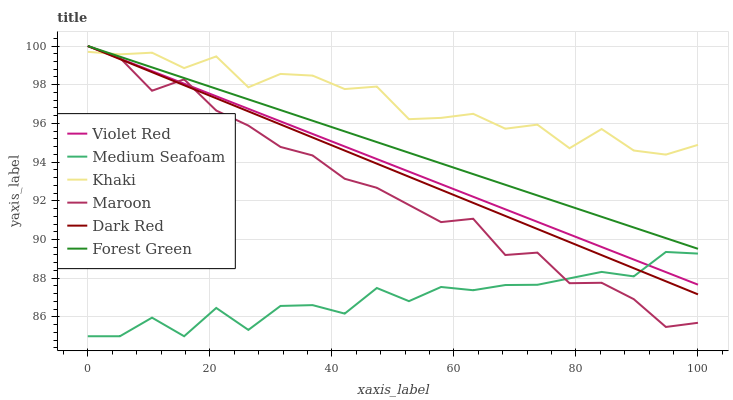Does Dark Red have the minimum area under the curve?
Answer yes or no. No. Does Dark Red have the maximum area under the curve?
Answer yes or no. No. Is Khaki the smoothest?
Answer yes or no. No. Is Khaki the roughest?
Answer yes or no. No. Does Dark Red have the lowest value?
Answer yes or no. No. Does Khaki have the highest value?
Answer yes or no. No. Is Medium Seafoam less than Khaki?
Answer yes or no. Yes. Is Khaki greater than Medium Seafoam?
Answer yes or no. Yes. Does Medium Seafoam intersect Khaki?
Answer yes or no. No. 